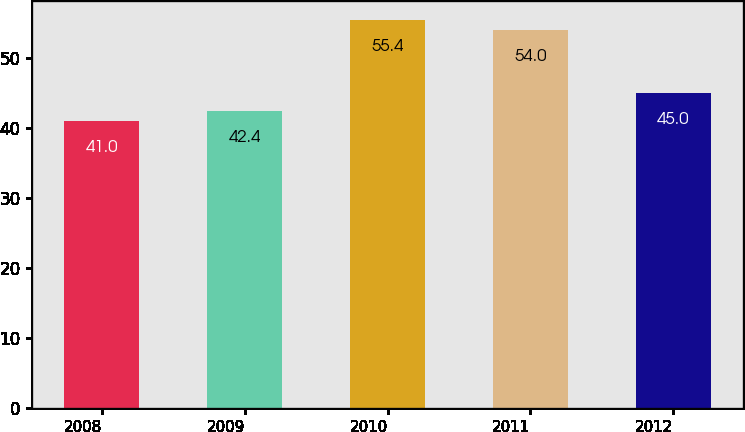Convert chart to OTSL. <chart><loc_0><loc_0><loc_500><loc_500><bar_chart><fcel>2008<fcel>2009<fcel>2010<fcel>2011<fcel>2012<nl><fcel>41<fcel>42.4<fcel>55.4<fcel>54<fcel>45<nl></chart> 